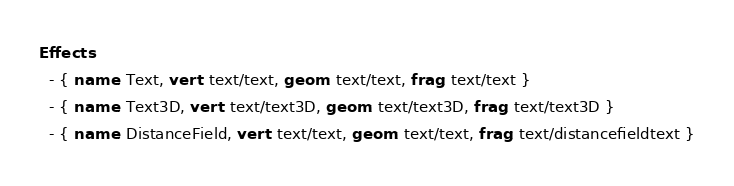Convert code to text. <code><loc_0><loc_0><loc_500><loc_500><_YAML_>Effects:
  - { name: Text, vert: text/text, geom: text/text, frag: text/text }
  - { name: Text3D, vert: text/text3D, geom: text/text3D, frag: text/text3D }
  - { name: DistanceField, vert: text/text, geom: text/text, frag: text/distancefieldtext }</code> 